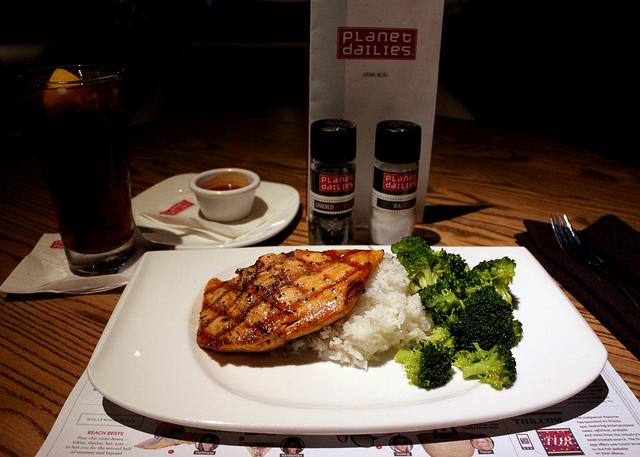What is in the picture?
Write a very short answer. Food. Which two condiments do you see clearly?
Answer briefly. Salt and pepper. Are these ribs?
Quick response, please. No. What is the food in the foreground?
Short answer required. Broccoli. What shape is the plate?
Short answer required. Square. 